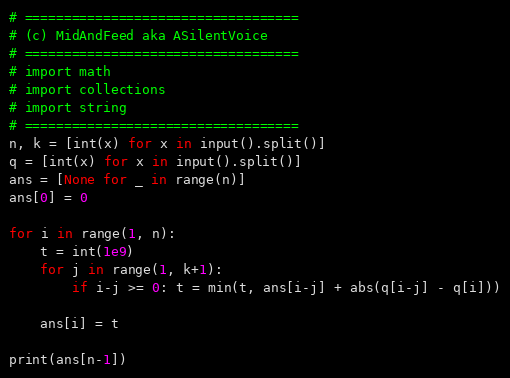<code> <loc_0><loc_0><loc_500><loc_500><_Python_># ===================================
# (c) MidAndFeed aka ASilentVoice
# ===================================
# import math 
# import collections
# import string
# ===================================
n, k = [int(x) for x in input().split()]
q = [int(x) for x in input().split()]
ans = [None for _ in range(n)]
ans[0] = 0

for i in range(1, n):
	t = int(1e9)
	for j in range(1, k+1):
		if i-j >= 0: t = min(t, ans[i-j] + abs(q[i-j] - q[i]))

	ans[i] = t

print(ans[n-1])
</code> 